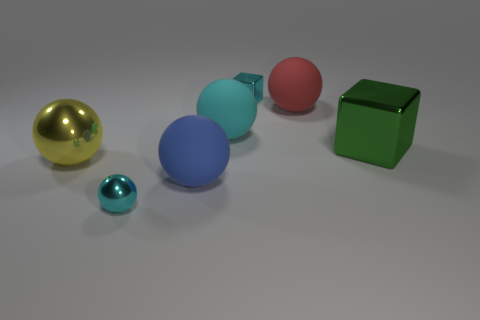Subtract 2 spheres. How many spheres are left? 3 Subtract all cyan shiny balls. How many balls are left? 4 Subtract all blue balls. How many balls are left? 4 Subtract all purple balls. Subtract all purple cylinders. How many balls are left? 5 Add 3 large cyan rubber spheres. How many objects exist? 10 Subtract all cubes. How many objects are left? 5 Add 1 big spheres. How many big spheres are left? 5 Add 4 yellow metallic spheres. How many yellow metallic spheres exist? 5 Subtract 0 gray cubes. How many objects are left? 7 Subtract all large cyan metal cylinders. Subtract all red balls. How many objects are left? 6 